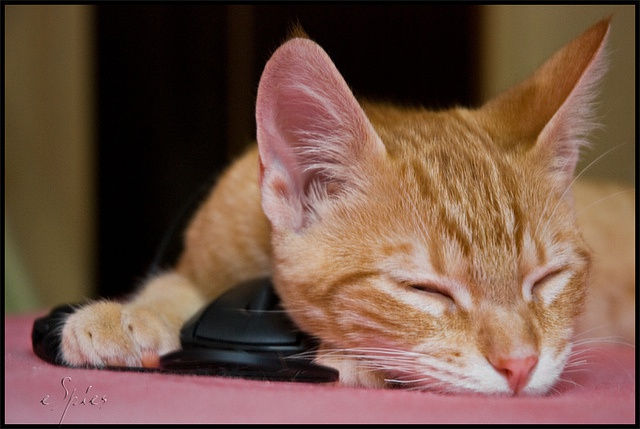Describe the objects in this image and their specific colors. I can see cat in black, brown, and tan tones and mouse in black, gray, and darkblue tones in this image. 